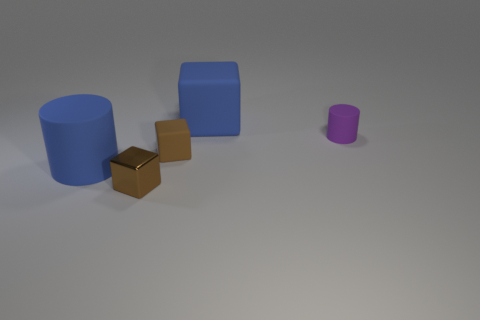Subtract all green spheres. How many brown cubes are left? 2 Subtract all blue blocks. How many blocks are left? 2 Add 3 tiny brown metallic blocks. How many objects exist? 8 Subtract all cubes. How many objects are left? 2 Add 2 tiny matte cubes. How many tiny matte cubes are left? 3 Add 3 tiny purple cylinders. How many tiny purple cylinders exist? 4 Subtract 0 yellow cubes. How many objects are left? 5 Subtract all cubes. Subtract all purple matte things. How many objects are left? 1 